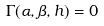<formula> <loc_0><loc_0><loc_500><loc_500>\Gamma ( \alpha , \beta , h ) = 0</formula> 